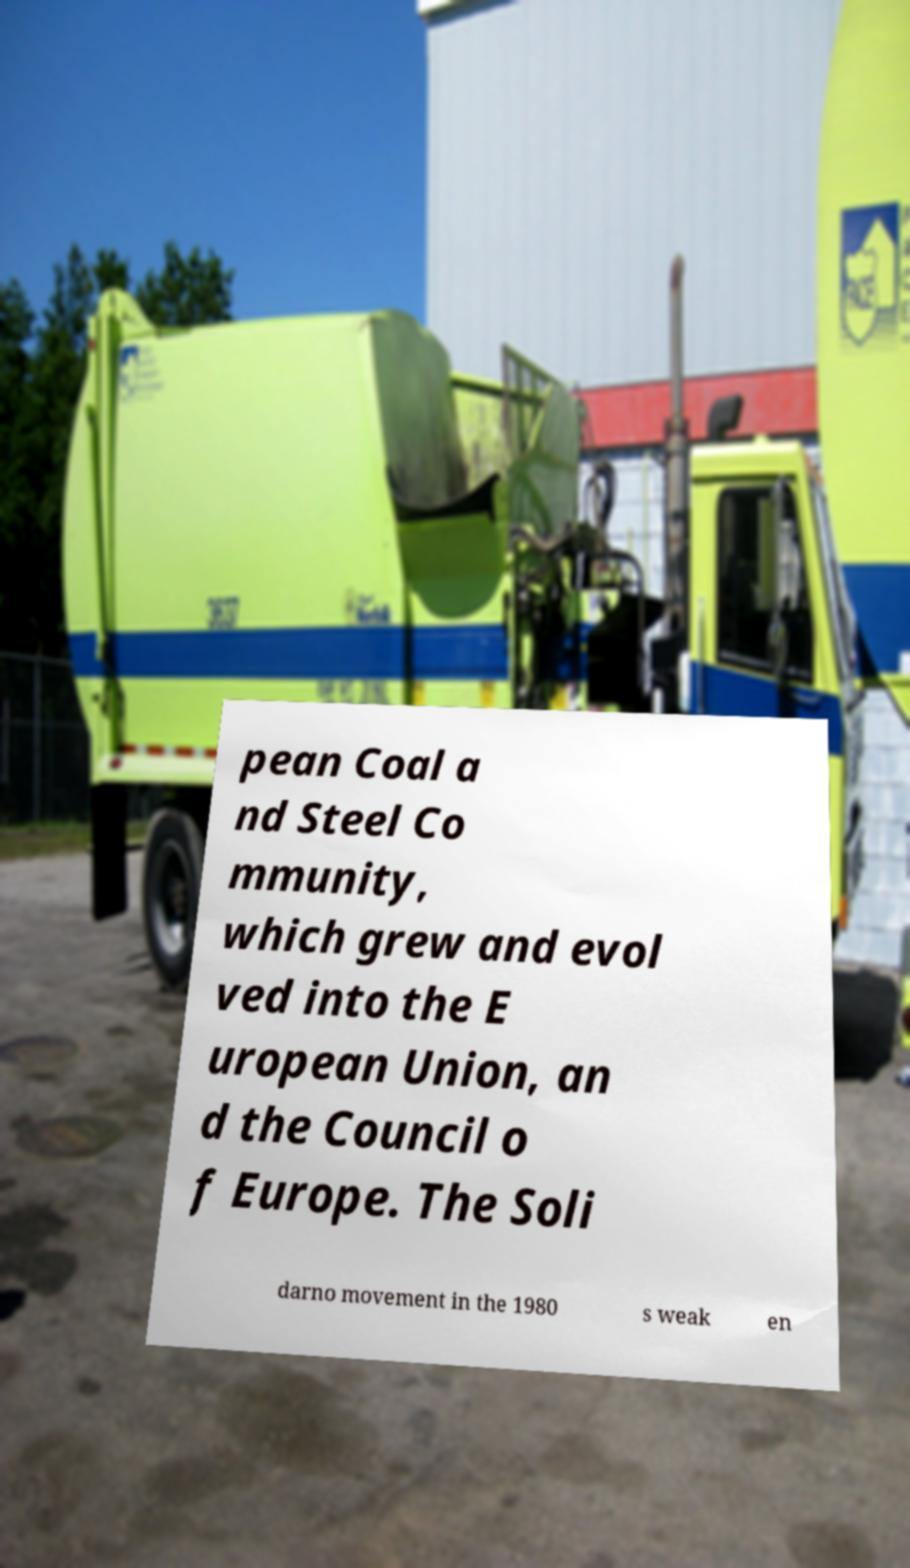I need the written content from this picture converted into text. Can you do that? pean Coal a nd Steel Co mmunity, which grew and evol ved into the E uropean Union, an d the Council o f Europe. The Soli darno movement in the 1980 s weak en 